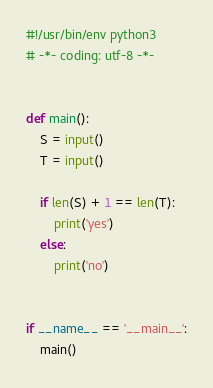<code> <loc_0><loc_0><loc_500><loc_500><_Python_>#!/usr/bin/env python3
# -*- coding: utf-8 -*-


def main():
    S = input()
    T = input()

    if len(S) + 1 == len(T):
        print('yes')
    else:
        print('no')


if __name__ == '__main__':
    main()</code> 